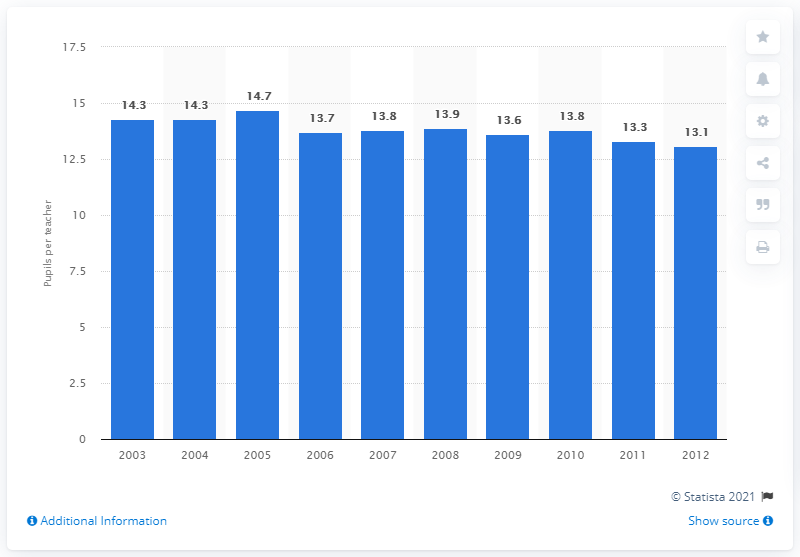Indicate a few pertinent items in this graphic. In 2005, the average number of students per teacher in Finland was 14.7. 